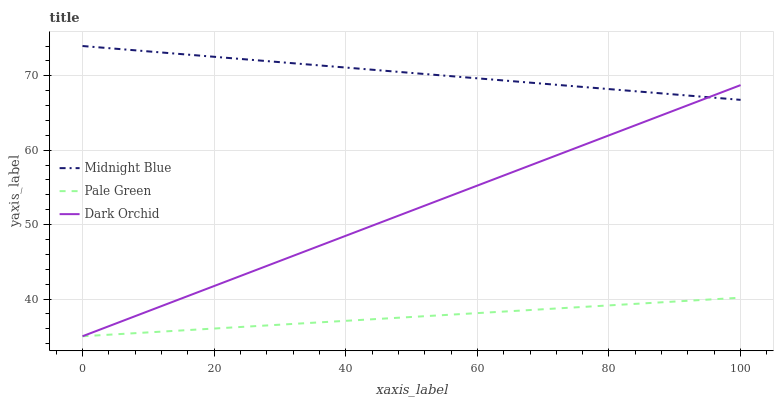Does Pale Green have the minimum area under the curve?
Answer yes or no. Yes. Does Midnight Blue have the maximum area under the curve?
Answer yes or no. Yes. Does Dark Orchid have the minimum area under the curve?
Answer yes or no. No. Does Dark Orchid have the maximum area under the curve?
Answer yes or no. No. Is Pale Green the smoothest?
Answer yes or no. Yes. Is Midnight Blue the roughest?
Answer yes or no. Yes. Is Dark Orchid the smoothest?
Answer yes or no. No. Is Dark Orchid the roughest?
Answer yes or no. No. Does Pale Green have the lowest value?
Answer yes or no. Yes. Does Midnight Blue have the lowest value?
Answer yes or no. No. Does Midnight Blue have the highest value?
Answer yes or no. Yes. Does Dark Orchid have the highest value?
Answer yes or no. No. Is Pale Green less than Midnight Blue?
Answer yes or no. Yes. Is Midnight Blue greater than Pale Green?
Answer yes or no. Yes. Does Dark Orchid intersect Midnight Blue?
Answer yes or no. Yes. Is Dark Orchid less than Midnight Blue?
Answer yes or no. No. Is Dark Orchid greater than Midnight Blue?
Answer yes or no. No. Does Pale Green intersect Midnight Blue?
Answer yes or no. No. 